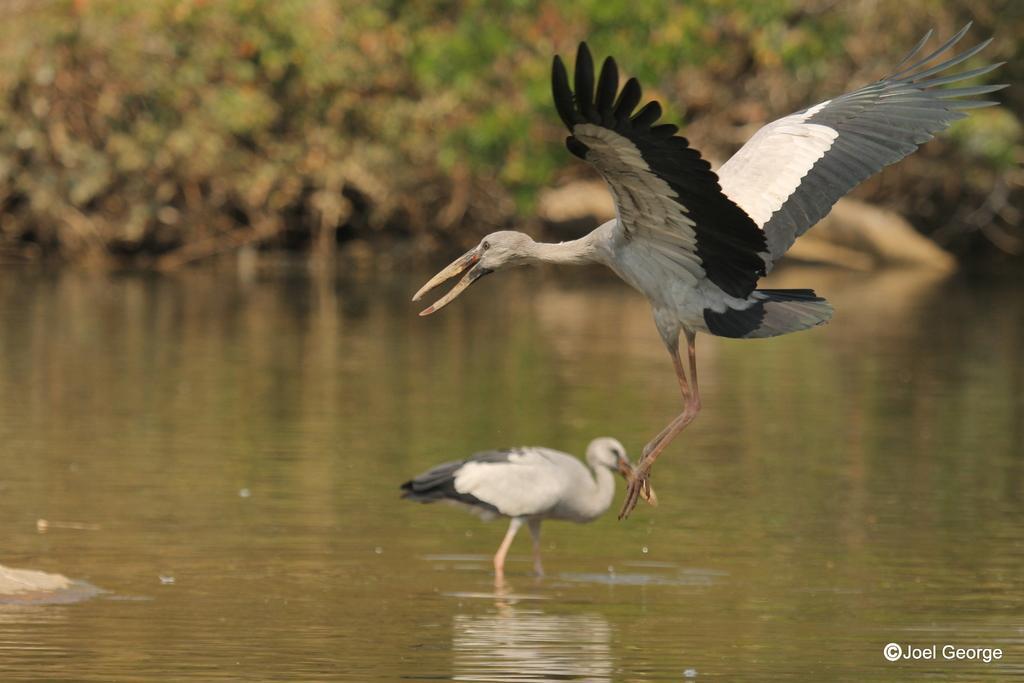Can you describe this image briefly? In the center of the image there are birds. At the bottom of the image there is water. In the background of the image there are trees. 